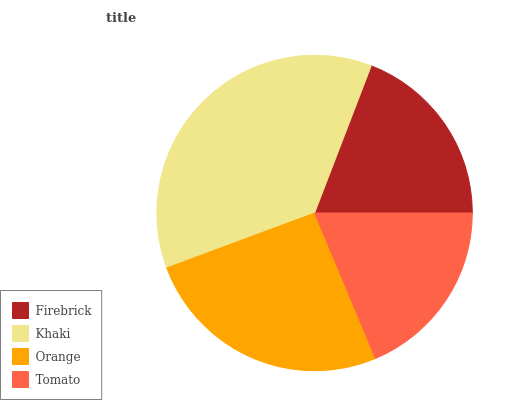Is Tomato the minimum?
Answer yes or no. Yes. Is Khaki the maximum?
Answer yes or no. Yes. Is Orange the minimum?
Answer yes or no. No. Is Orange the maximum?
Answer yes or no. No. Is Khaki greater than Orange?
Answer yes or no. Yes. Is Orange less than Khaki?
Answer yes or no. Yes. Is Orange greater than Khaki?
Answer yes or no. No. Is Khaki less than Orange?
Answer yes or no. No. Is Orange the high median?
Answer yes or no. Yes. Is Firebrick the low median?
Answer yes or no. Yes. Is Firebrick the high median?
Answer yes or no. No. Is Tomato the low median?
Answer yes or no. No. 